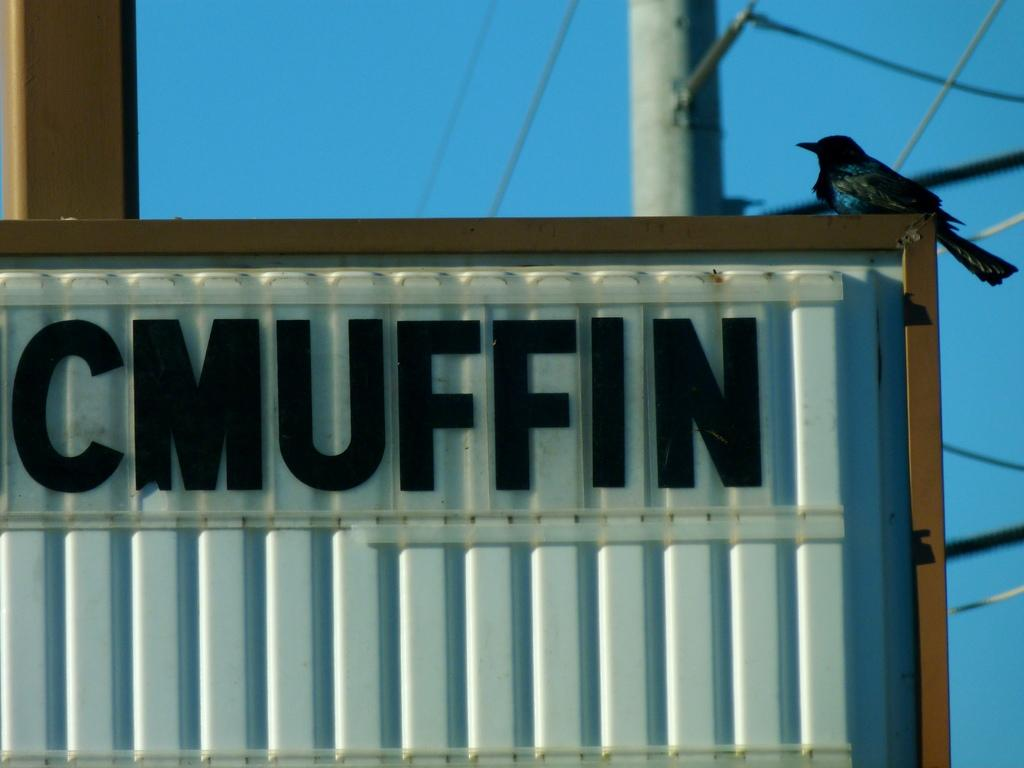What can be found in the image that contains written information? There is text in the image. What type of animal is present in the image? There is a bird in the image. Where is the bird located in the image? The bird is on a container. What can be seen in the background of the image? There are wires and a pole in the background of the image. How many oranges are being held by the bird in the image? There are no oranges present in the image; the bird is on a container. Can you describe the snakes that are coiled around the wires in the background? There are no snakes present in the image; only wires and a pole can be seen in the background. 